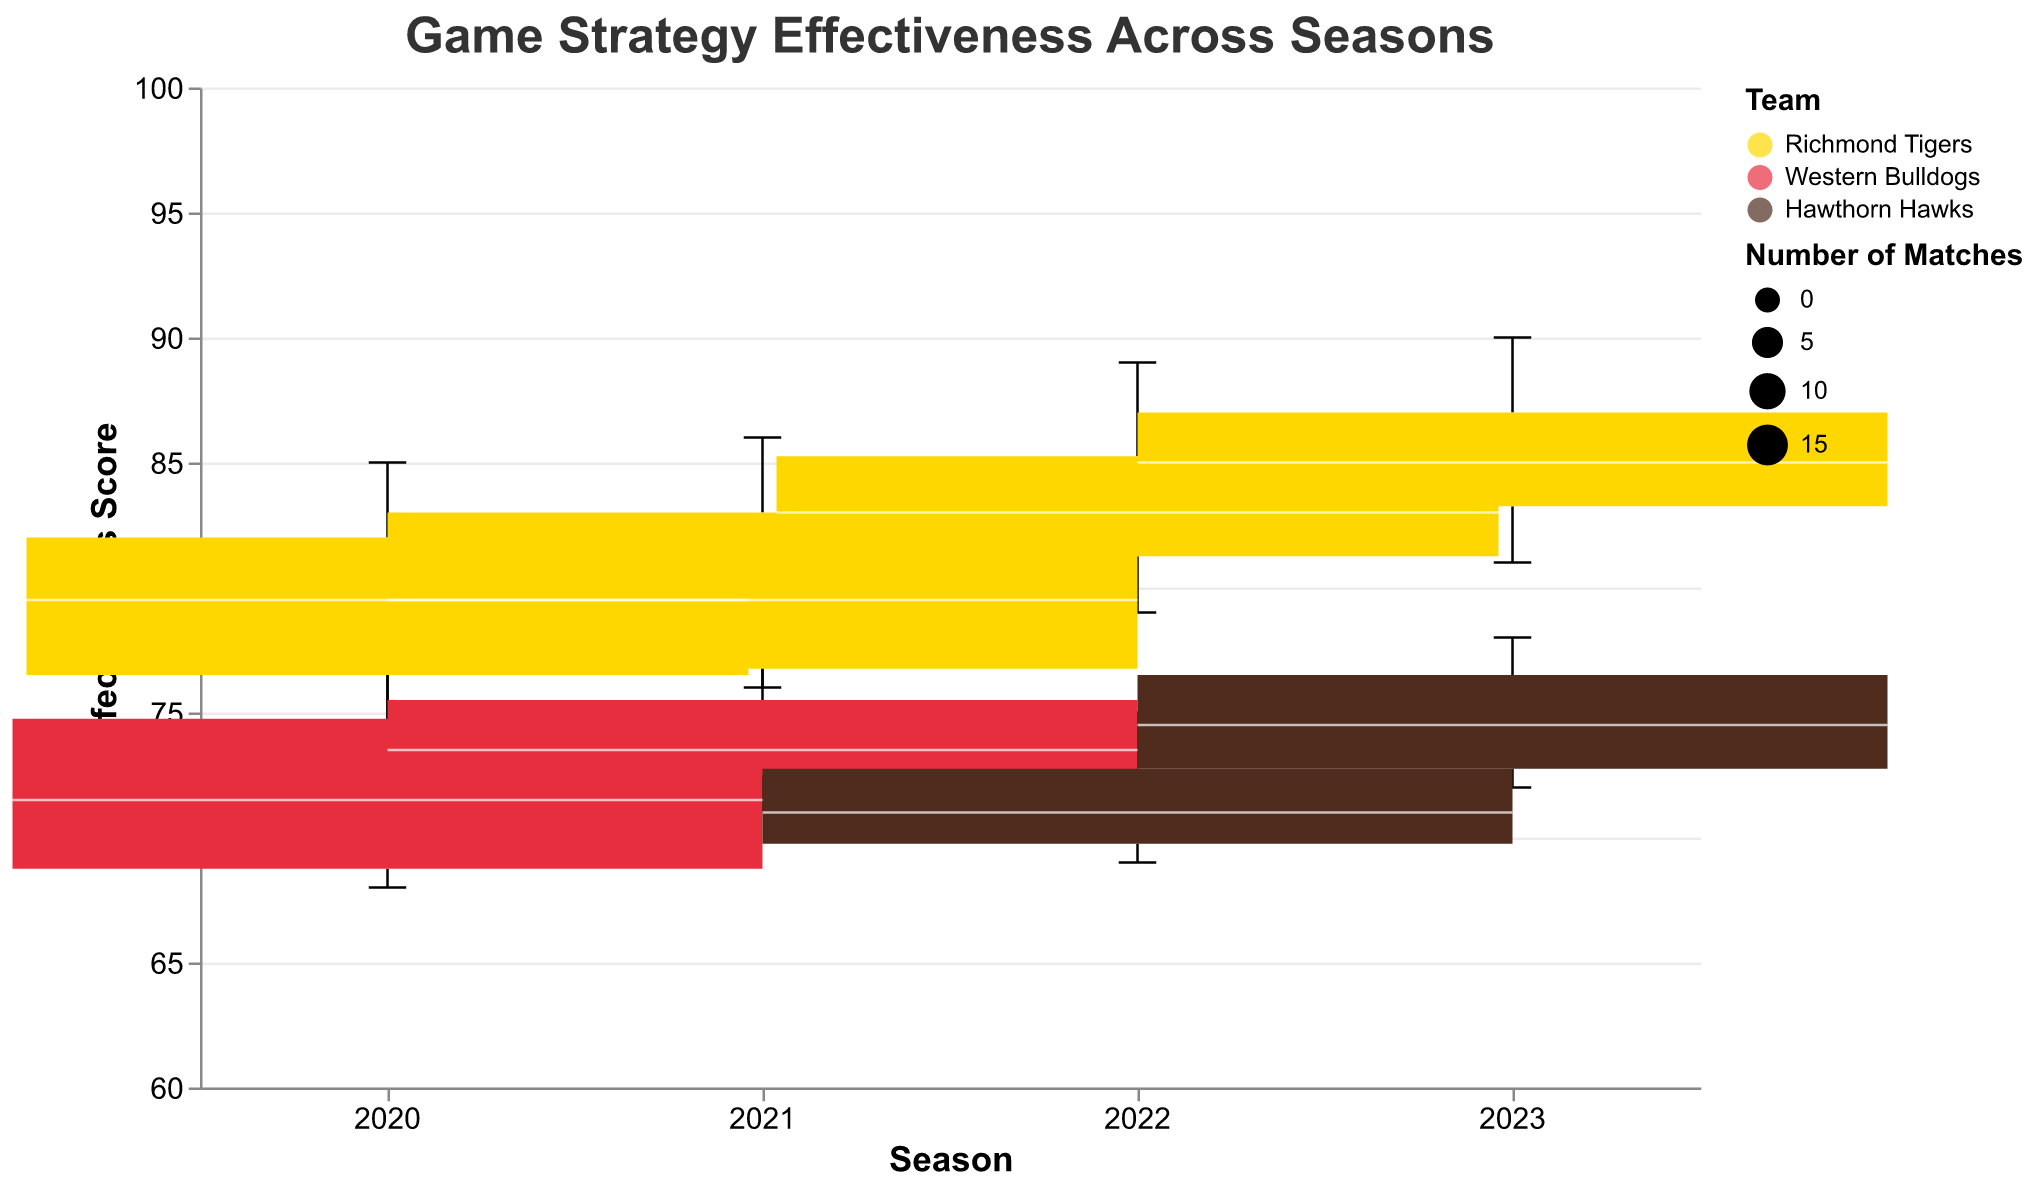What is the title of the plot? The title of the plot is usually at the top and is used to describe the overall content of the figure. In this case, it reads "Game Strategy Effectiveness Across Seasons".
Answer: Game Strategy Effectiveness Across Seasons Which team used the "Zone Defense" tactic with the highest effectiveness score in 2020? To find this, locate the 2020 data points, then look at the "Zone Defense" tactic and identify the team with the highest effectiveness score. The Richmond Tigers have the highest score of 85.
Answer: Richmond Tigers What is the range of effectiveness scores for the "Counter-Attack" tactic by the Richmond Tigers across all seasons? Look at all data points where the team is the Richmond Tigers and the tactic is "Counter-Attack". The scores are 78 (2020), 82 (2021), 84 (2022), and 86 (2023). The range is from the lowest score (78) to the highest score (86).
Answer: 78 - 86 How many matches did the Western Bulldogs play in 2021? Refer to the data points for the Western Bulldogs in the 2021 season. All data points show that they played 18 matches across different tactics.
Answer: 18 What was the effectiveness score of "Set Plays" for the Richmond Tigers in 2023? Look for the 2023 data points for the Richmond Tigers and find the entry for "Set Plays". The effectiveness score is listed as 84.
Answer: 84 Which tactic for the Richmond Tigers has the highest median effectiveness score over the years? Observe all the box plots for different tactics by the Richmond Tigers and identify which tactic has the highest median value. "Zone Defense" consistently shows higher median values relative to the other tactics.
Answer: Zone Defense Compare the effectiveness of "Man-to-Man Defense" between the Richmond Tigers and Hawthorn Hawks in 2023. Which team performed better? Identify the 2023 data points for both teams regarding "Man-to-Man Defense". The Richmond Tigers scored 81, whereas the Hawthorn Hawks scored 72. Therefore, the Richmond Tigers performed better.
Answer: Richmond Tigers Between 2020 and 2023, is there an increasing trend in the effectiveness score of "Counter-Attack" for the Richmond Tigers? Review the effectiveness scores for "Counter-Attack" for the Richmond Tigers from 2020 to 2023. The scores are 78 (2020), 82 (2021), 84 (2022), and 86 (2023). The scores show an increasing trend over the years.
Answer: Yes What is the average effectiveness score for "Zone Defense" by the Hawthorn Hawks over all available seasons? Find the effectiveness scores for the Hawthorn Hawks using "Zone Defense": 75 (2022) and 78 (2023). Calculate the average: (75 + 78) / 2 = 76.5.
Answer: 76.5 